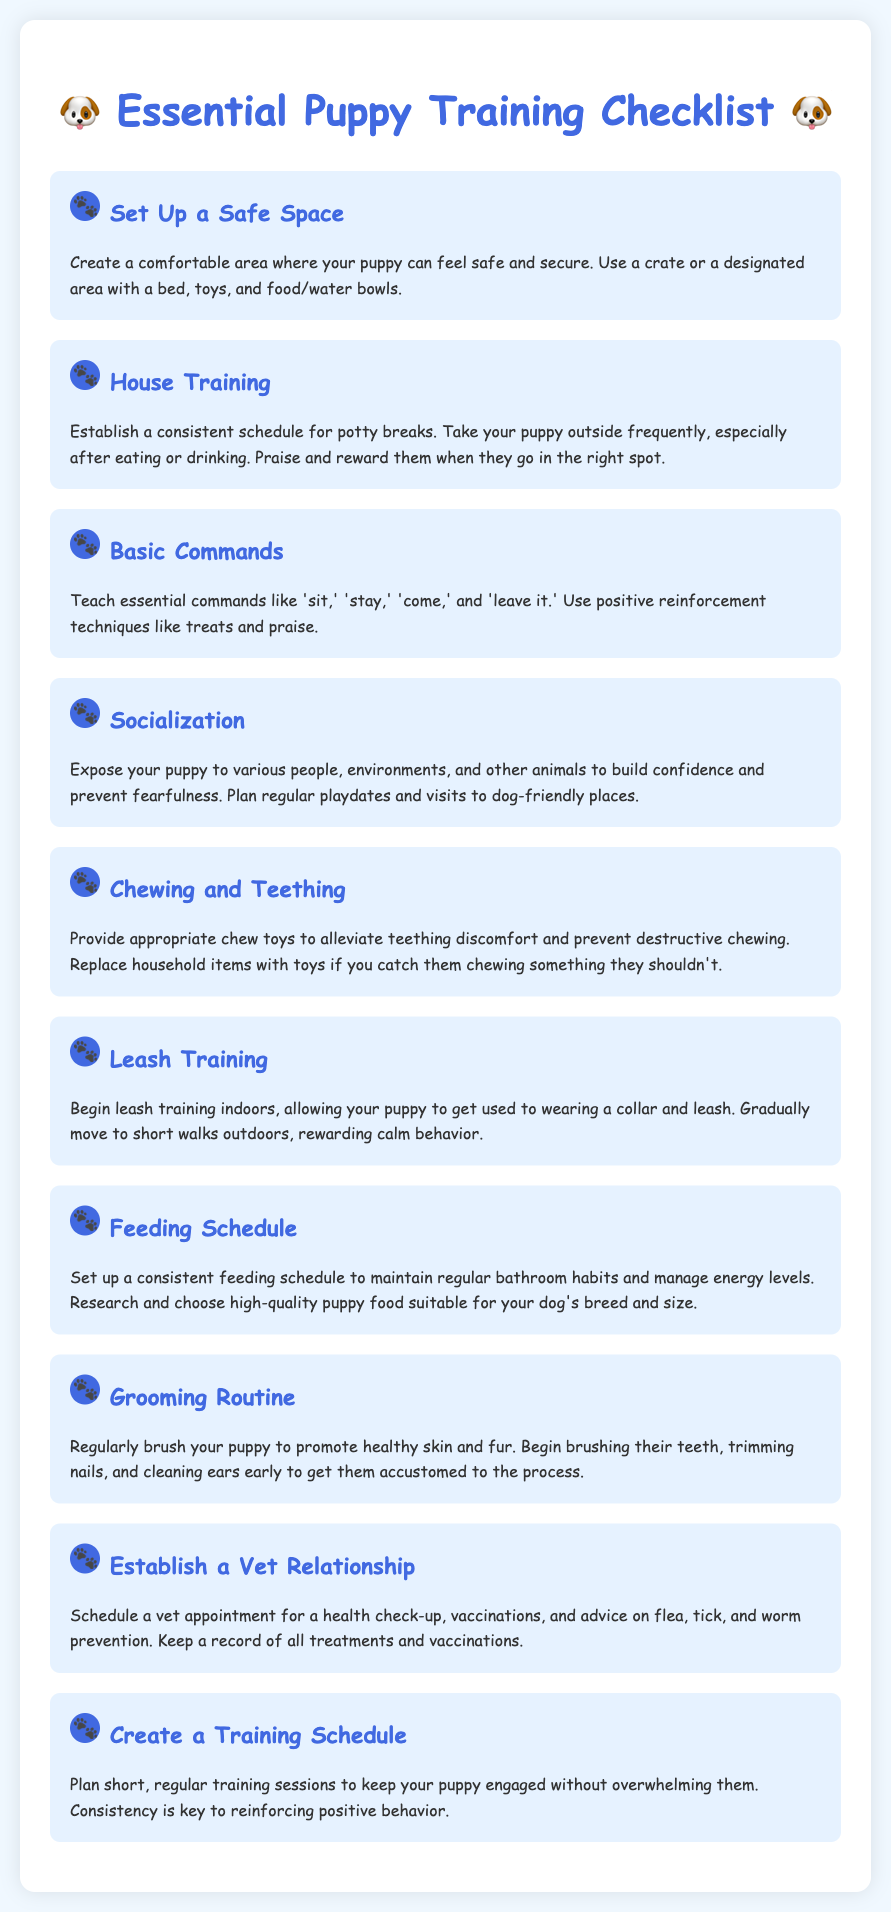What is the first item on the checklist? The first item is "Set Up a Safe Space."
Answer: Set Up a Safe Space How many basic commands are mentioned? The checklist mentions four basic commands: "sit," "stay," "come," and "leave it."
Answer: Four What is recommended to help with teething discomfort? The checklist suggests providing appropriate chew toys.
Answer: Appropriate chew toys What should you do to establish a consistent feeding schedule? You should research and choose high-quality puppy food suitable for your dog's breed and size.
Answer: Research and choose high-quality puppy food What is essential for building confidence in a puppy? Exposing your puppy to various people, environments, and other animals is essential.
Answer: Socialization How many items are listed in the checklist? The checklist includes ten items in total.
Answer: Ten What should you plan for training your puppy? You should plan short, regular training sessions to keep your puppy engaged.
Answer: Short, regular training sessions What is the purpose of establishing a vet relationship? The purpose is for health check-ups, vaccinations, and advice on prevention.
Answer: Health check-ups and vaccinations 